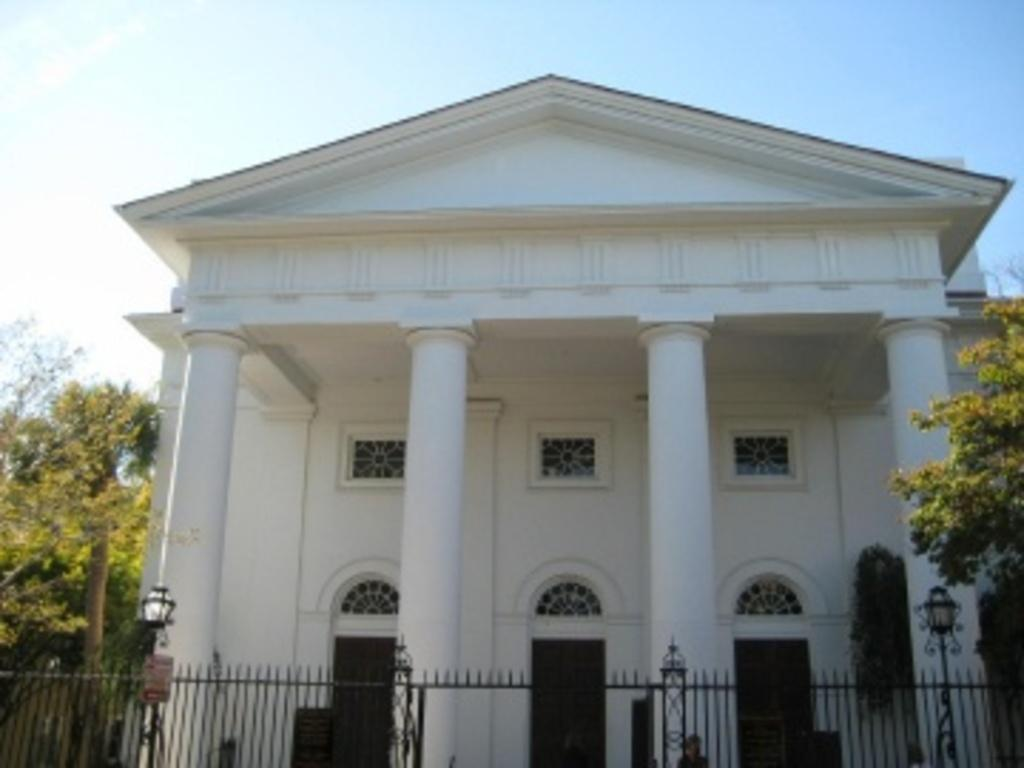What type of structure is visible in the image? There is a building in the image. What is the color of the building? The building is white. What is located in front of the building? There is a fence in front of the building. What type of vegetation is present on either side of the building? There are trees on either side of the building. What type of canvas is being used by the pig in the image? There is no pig or canvas present in the image. What level of difficulty is the building on in the image? The image does not indicate any level of difficulty for the building. 